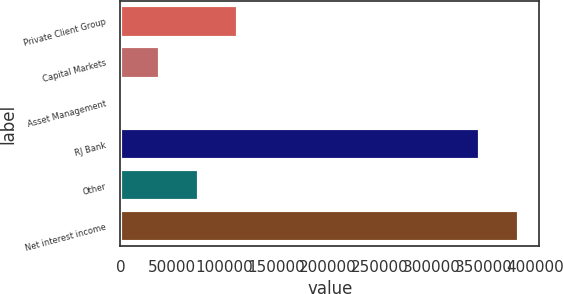Convert chart. <chart><loc_0><loc_0><loc_500><loc_500><bar_chart><fcel>Private Client Group<fcel>Capital Markets<fcel>Asset Management<fcel>RJ Bank<fcel>Other<fcel>Net interest income<nl><fcel>113103<fcel>37762.3<fcel>92<fcel>346757<fcel>75432.6<fcel>384427<nl></chart> 